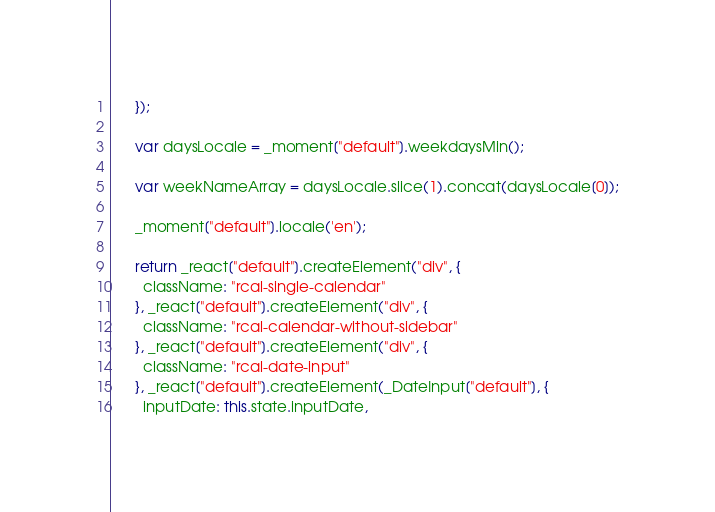Convert code to text. <code><loc_0><loc_0><loc_500><loc_500><_JavaScript_>      });

      var daysLocale = _moment["default"].weekdaysMin();

      var weekNameArray = daysLocale.slice(1).concat(daysLocale[0]);

      _moment["default"].locale('en');

      return _react["default"].createElement("div", {
        className: "rcal-single-calendar"
      }, _react["default"].createElement("div", {
        className: "rcal-calendar-without-sidebar"
      }, _react["default"].createElement("div", {
        className: "rcal-date-input"
      }, _react["default"].createElement(_DateInput["default"], {
        inputDate: this.state.inputDate,</code> 